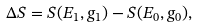<formula> <loc_0><loc_0><loc_500><loc_500>\Delta S = S ( E _ { 1 } , g _ { 1 } ) - S ( E _ { 0 } , g _ { 0 } ) ,</formula> 